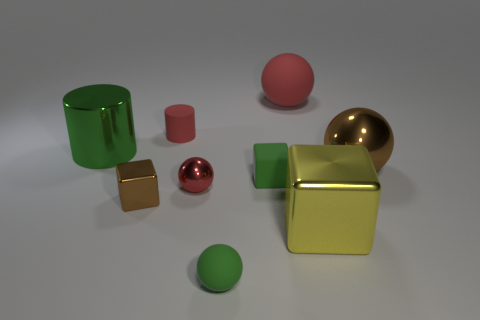Subtract all big shiny balls. How many balls are left? 3 Add 1 green rubber balls. How many objects exist? 10 Subtract all green balls. How many balls are left? 3 Subtract all balls. How many objects are left? 5 Subtract 3 spheres. How many spheres are left? 1 Subtract all gray blocks. How many red spheres are left? 2 Subtract 0 brown cylinders. How many objects are left? 9 Subtract all purple cylinders. Subtract all yellow blocks. How many cylinders are left? 2 Subtract all big brown balls. Subtract all red shiny objects. How many objects are left? 7 Add 4 tiny cubes. How many tiny cubes are left? 6 